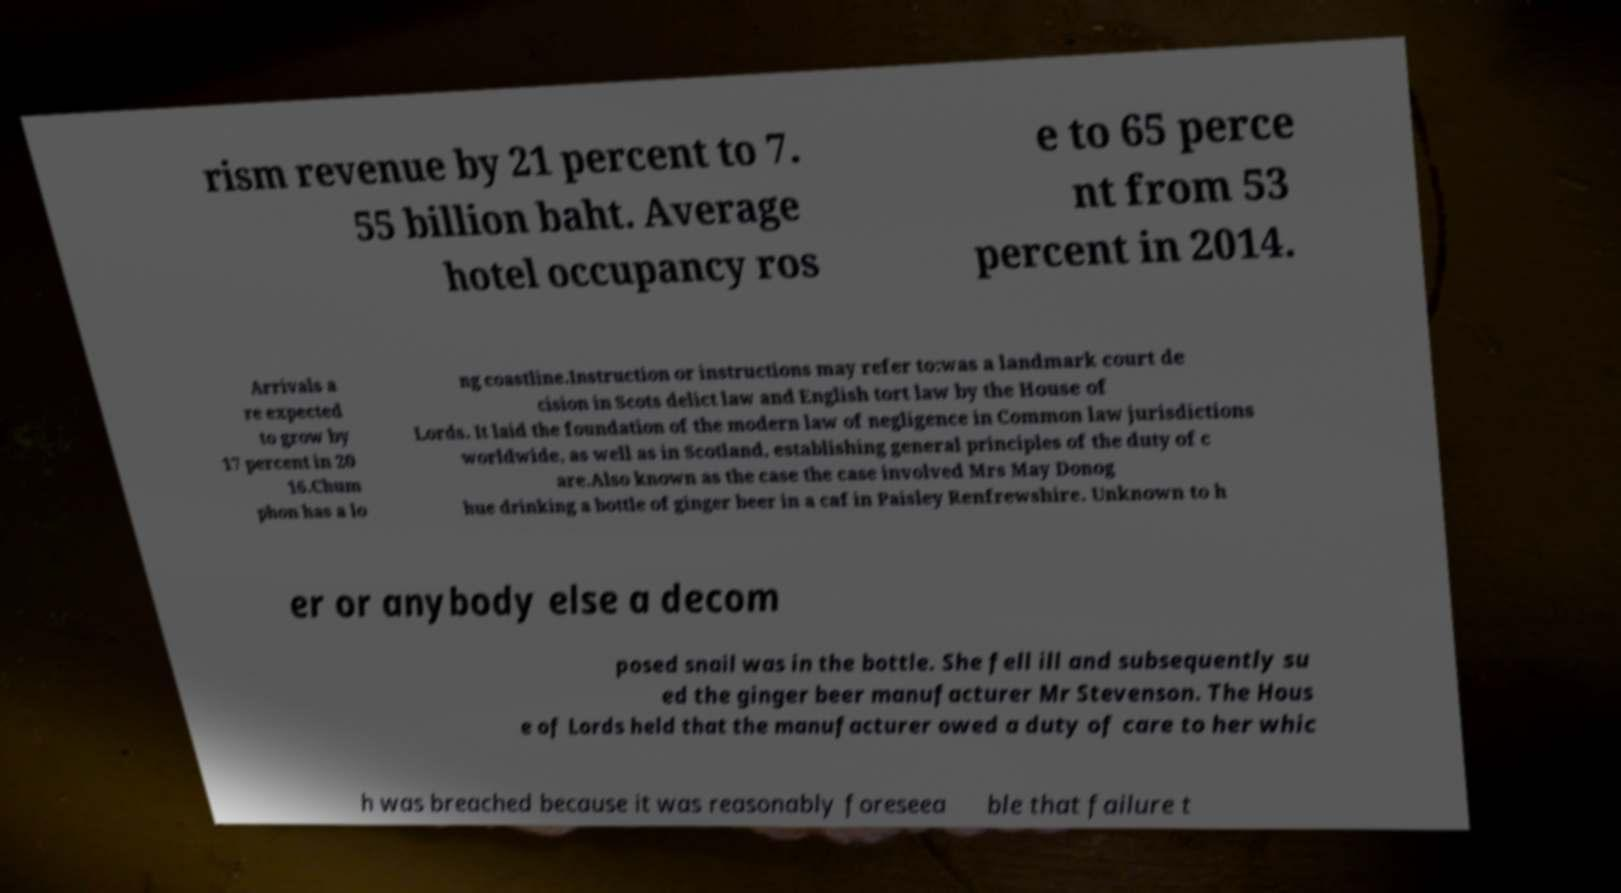Please identify and transcribe the text found in this image. rism revenue by 21 percent to 7. 55 billion baht. Average hotel occupancy ros e to 65 perce nt from 53 percent in 2014. Arrivals a re expected to grow by 17 percent in 20 16.Chum phon has a lo ng coastline.Instruction or instructions may refer to:was a landmark court de cision in Scots delict law and English tort law by the House of Lords. It laid the foundation of the modern law of negligence in Common law jurisdictions worldwide, as well as in Scotland, establishing general principles of the duty of c are.Also known as the case the case involved Mrs May Donog hue drinking a bottle of ginger beer in a caf in Paisley Renfrewshire. Unknown to h er or anybody else a decom posed snail was in the bottle. She fell ill and subsequently su ed the ginger beer manufacturer Mr Stevenson. The Hous e of Lords held that the manufacturer owed a duty of care to her whic h was breached because it was reasonably foreseea ble that failure t 